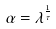<formula> <loc_0><loc_0><loc_500><loc_500>\alpha = \lambda ^ { \frac { 1 } { \tau } }</formula> 